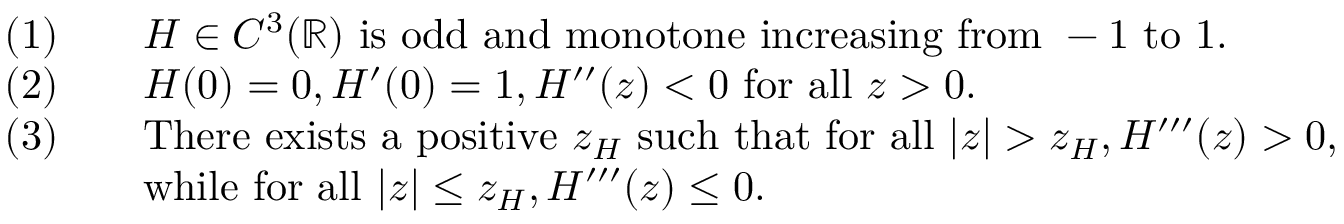Convert formula to latex. <formula><loc_0><loc_0><loc_500><loc_500>\begin{array} { r l } { ( 1 ) \quad } & { H \in C ^ { 3 } ( \mathbb { R } ) i s o d d a n d m o n o t o n e i n c r e a \sin g f r o m - 1 t o 1 . } \\ { ( 2 ) \quad } & { H ( 0 ) = 0 , H ^ { \prime } ( 0 ) = 1 , H ^ { \prime \prime } ( z ) < 0 f o r a l l z > 0 . } \\ { ( 3 ) \quad } & { T h e r e e x i s t s a p o s i t i v e z _ { H } s u c h t h a t f o r a l l | z | > z _ { H } , H ^ { \prime \prime \prime } ( z ) > 0 , } \\ & { w h i l e f o r a l l | z | \leq z _ { H } , H ^ { \prime \prime \prime } ( z ) \leq 0 . } \end{array}</formula> 